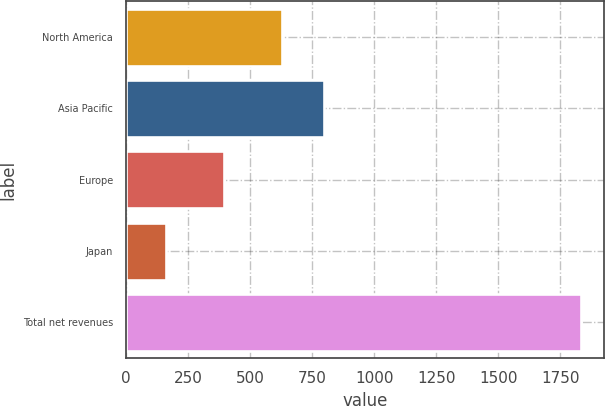<chart> <loc_0><loc_0><loc_500><loc_500><bar_chart><fcel>North America<fcel>Asia Pacific<fcel>Europe<fcel>Japan<fcel>Total net revenues<nl><fcel>628.5<fcel>795.77<fcel>395.1<fcel>160.9<fcel>1833.6<nl></chart> 